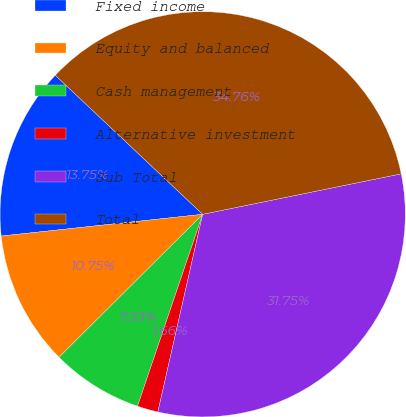<chart> <loc_0><loc_0><loc_500><loc_500><pie_chart><fcel>Fixed income<fcel>Equity and balanced<fcel>Cash management<fcel>Alternative investment<fcel>Sub Total<fcel>Total<nl><fcel>13.75%<fcel>10.75%<fcel>7.33%<fcel>1.66%<fcel>31.75%<fcel>34.76%<nl></chart> 